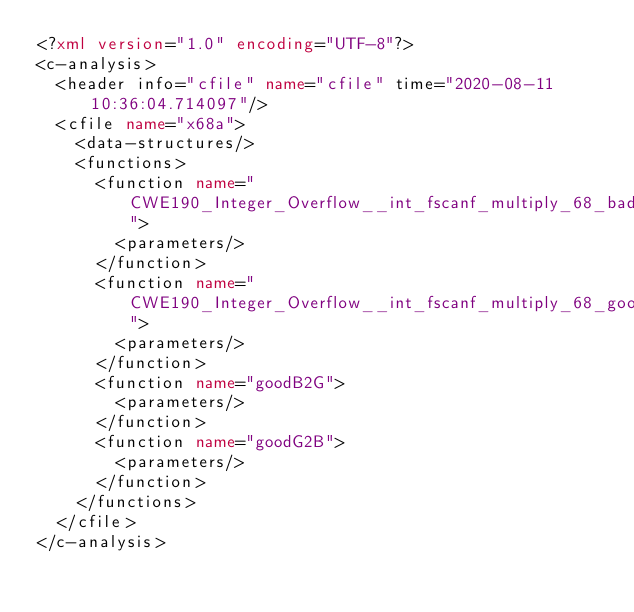<code> <loc_0><loc_0><loc_500><loc_500><_XML_><?xml version="1.0" encoding="UTF-8"?>
<c-analysis>
  <header info="cfile" name="cfile" time="2020-08-11 10:36:04.714097"/>
  <cfile name="x68a">
    <data-structures/>
    <functions>
      <function name="CWE190_Integer_Overflow__int_fscanf_multiply_68_bad">
        <parameters/>
      </function>
      <function name="CWE190_Integer_Overflow__int_fscanf_multiply_68_good">
        <parameters/>
      </function>
      <function name="goodB2G">
        <parameters/>
      </function>
      <function name="goodG2B">
        <parameters/>
      </function>
    </functions>
  </cfile>
</c-analysis>
</code> 